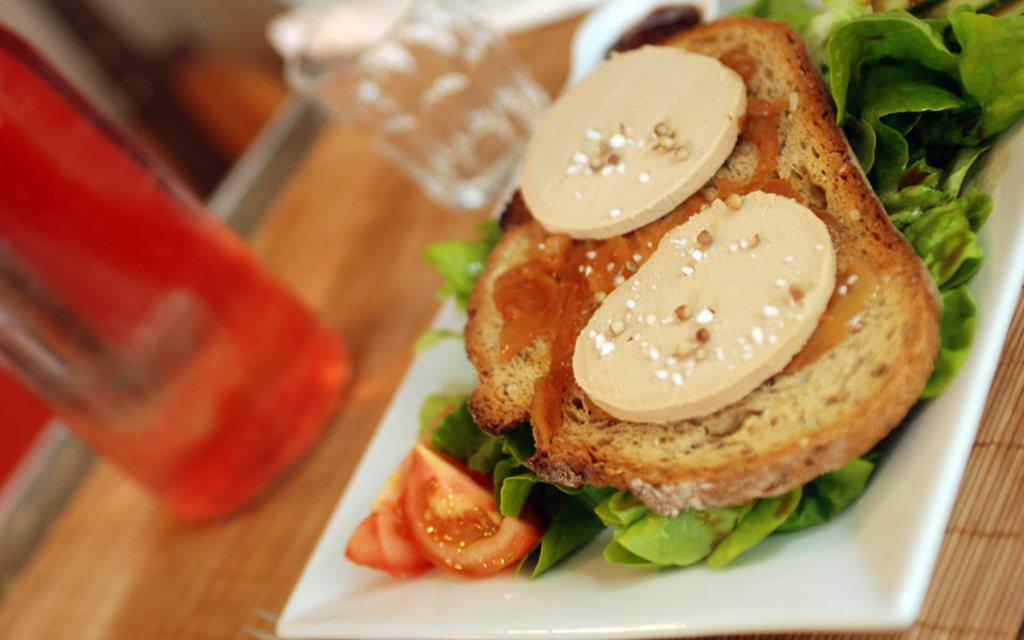What is placed on the plate in the image? There is an eatable item placed in a plate in the image. Where is the plate located? The plate is placed on a table. What other objects are on the table? There is a bottle and a glass on the table. How many children are holding pencils in the image? There are no children or pencils present in the image. 